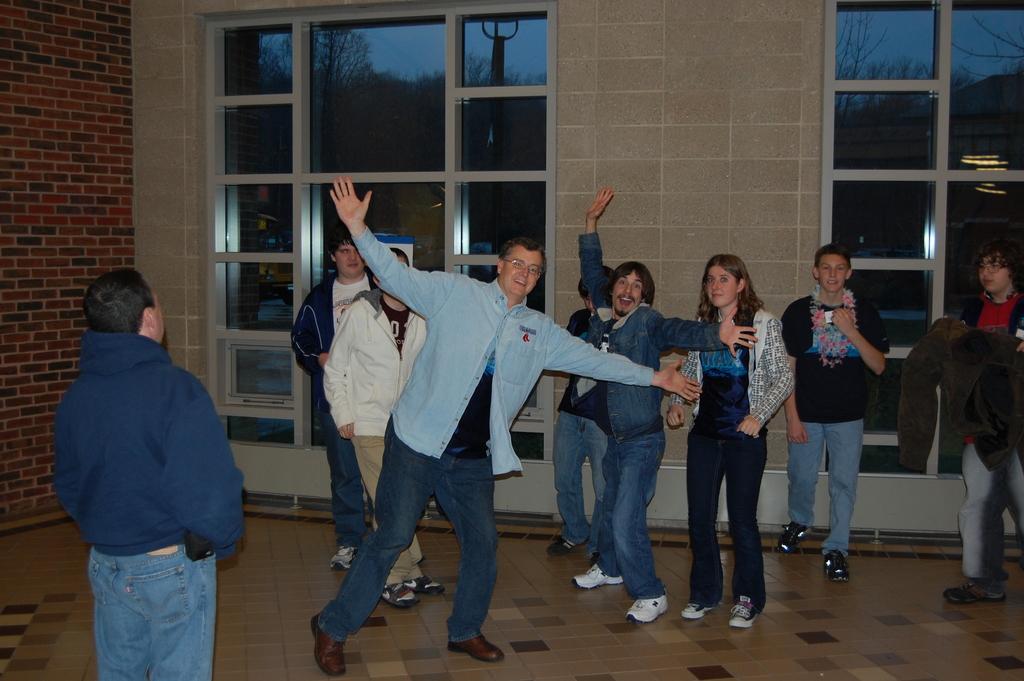Could you give a brief overview of what you see in this image? This image consists of persons standing and dancing. The man in the center is dancing and smiling. In the background there are windows. On the left side there is a wall which is red in colour and the woman in the center is standing and beside the woman there is a man dancing and smiling. 